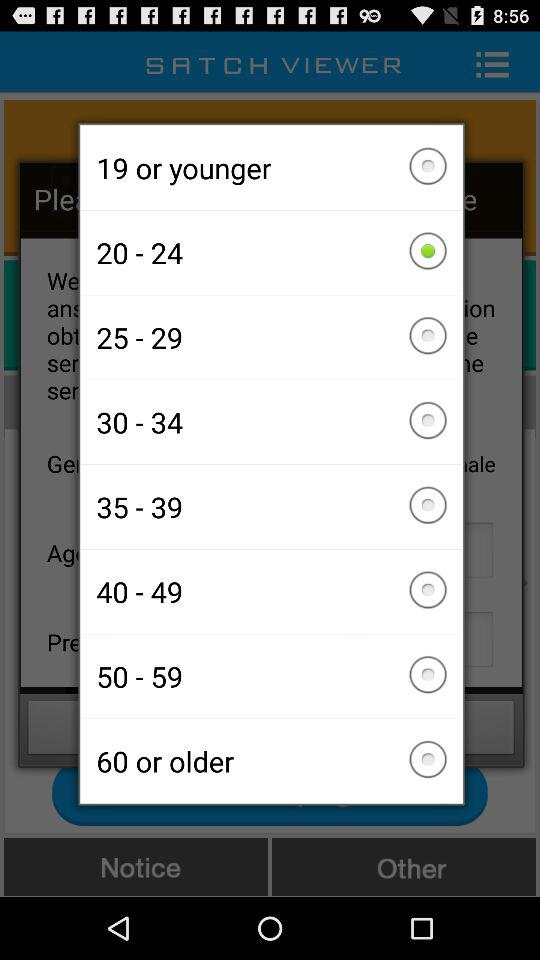Which option is selected? The selected option is "20 - 24". 